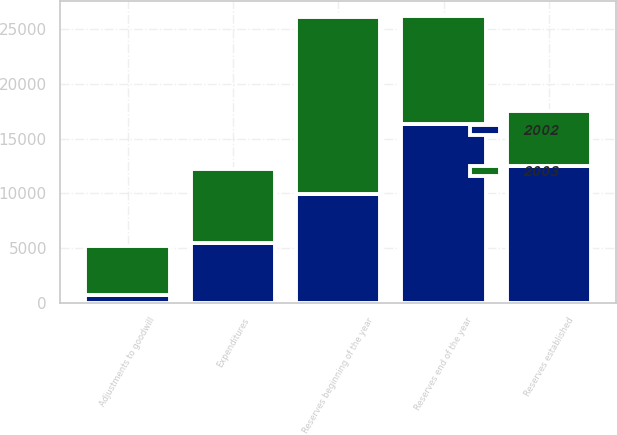<chart> <loc_0><loc_0><loc_500><loc_500><stacked_bar_chart><ecel><fcel>Reserves beginning of the year<fcel>Reserves established<fcel>Expenditures<fcel>Adjustments to goodwill<fcel>Reserves end of the year<nl><fcel>2003<fcel>16225<fcel>4963<fcel>6745<fcel>4537<fcel>9906<nl><fcel>2002<fcel>9906<fcel>12526<fcel>5436<fcel>674<fcel>16322<nl></chart> 